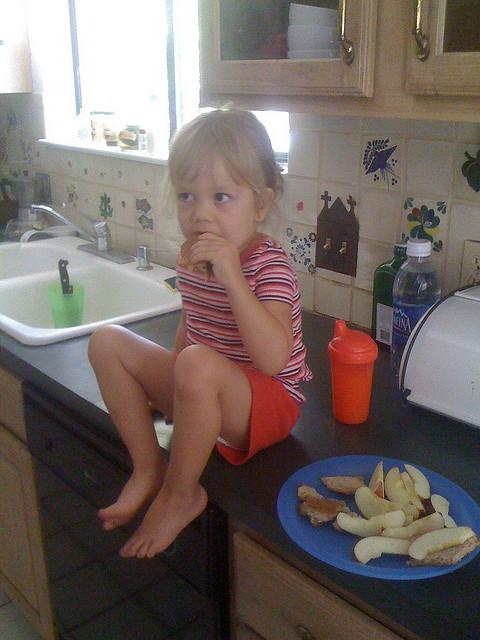What is a danger to the child?

Choices:
A) sharp knife
B) snake
C) poisonous frog
D) trampoline fall sharp knife 